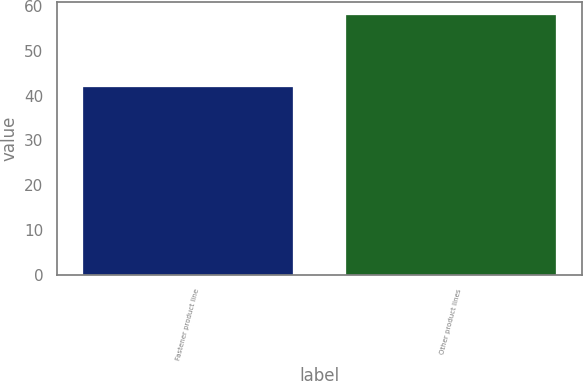Convert chart. <chart><loc_0><loc_0><loc_500><loc_500><bar_chart><fcel>Fastener product line<fcel>Other product lines<nl><fcel>42<fcel>58<nl></chart> 